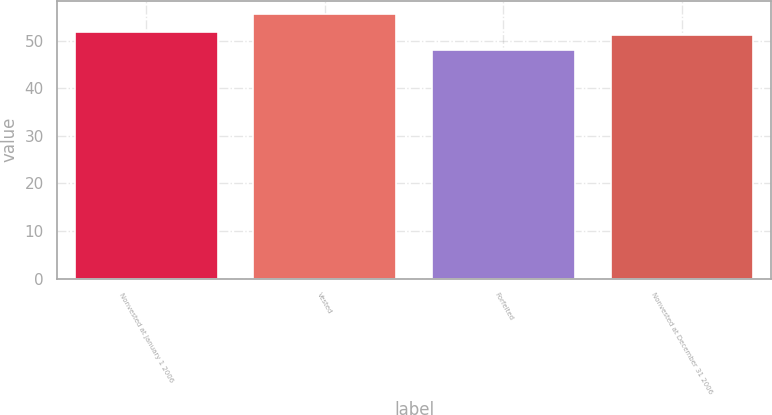Convert chart to OTSL. <chart><loc_0><loc_0><loc_500><loc_500><bar_chart><fcel>Nonvested at January 1 2006<fcel>Vested<fcel>Forfeited<fcel>Nonvested at December 31 2006<nl><fcel>51.89<fcel>55.56<fcel>48.1<fcel>51.14<nl></chart> 